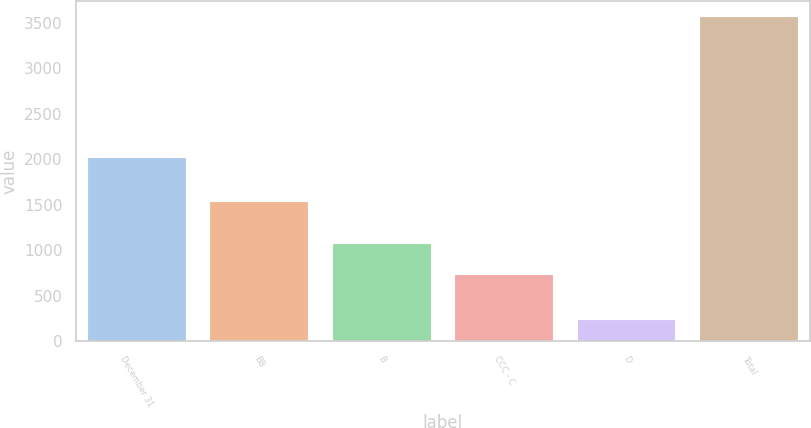Convert chart. <chart><loc_0><loc_0><loc_500><loc_500><bar_chart><fcel>December 31<fcel>BB<fcel>B<fcel>CCC - C<fcel>D<fcel>Total<nl><fcel>2012<fcel>1529<fcel>1075<fcel>724<fcel>239<fcel>3567<nl></chart> 